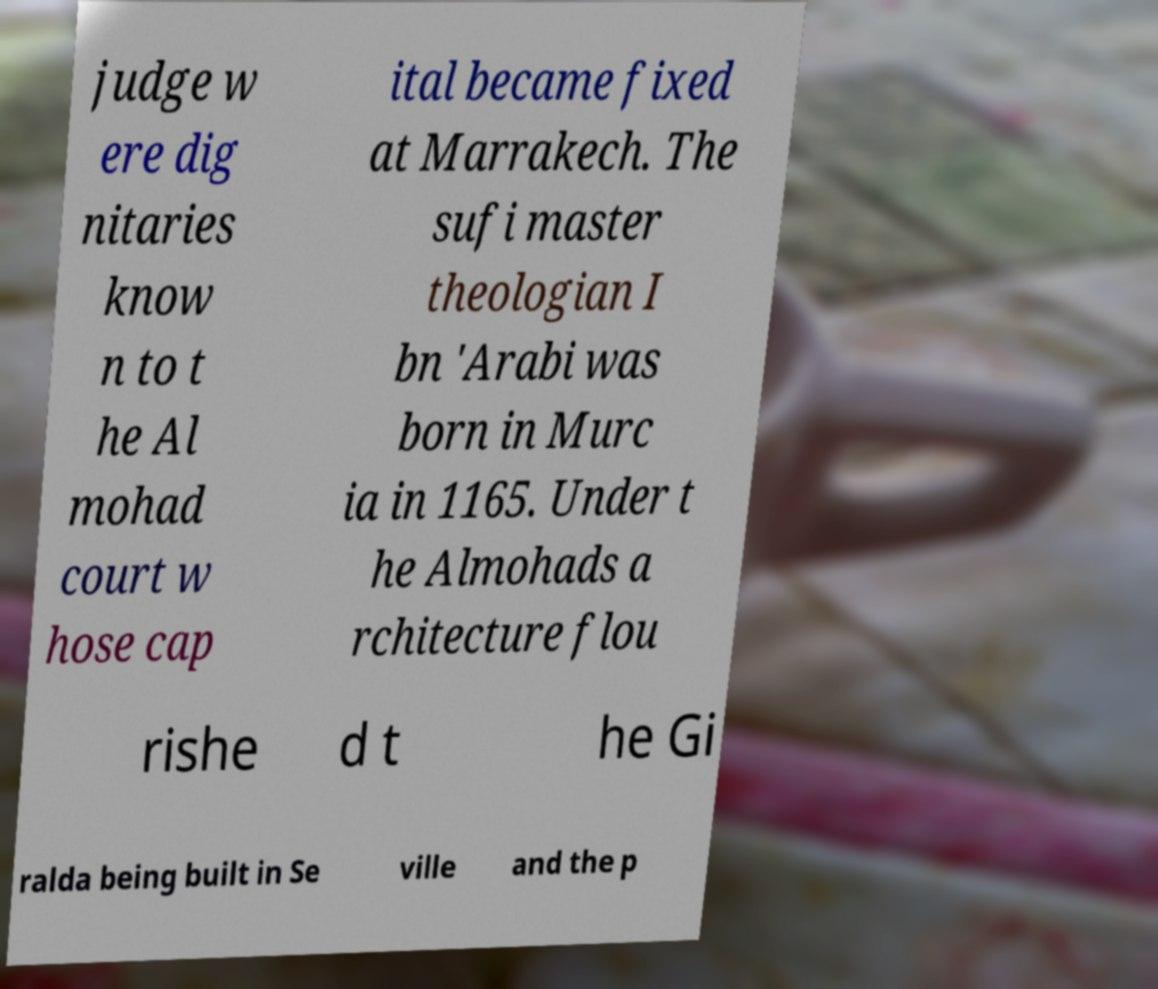Could you extract and type out the text from this image? judge w ere dig nitaries know n to t he Al mohad court w hose cap ital became fixed at Marrakech. The sufi master theologian I bn 'Arabi was born in Murc ia in 1165. Under t he Almohads a rchitecture flou rishe d t he Gi ralda being built in Se ville and the p 